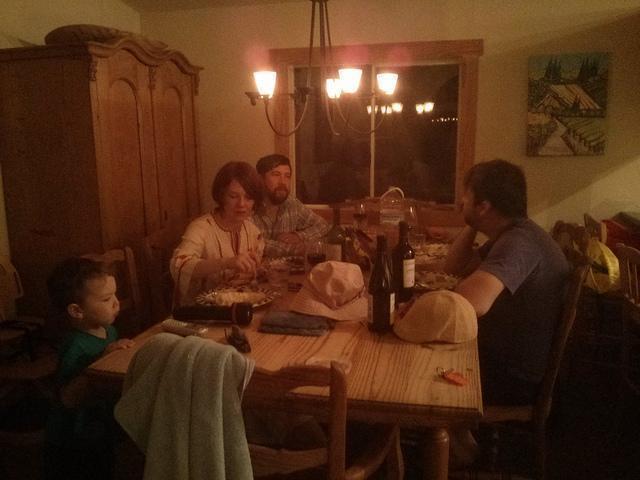Where are these people gathered?
Select the accurate answer and provide justification: `Answer: choice
Rationale: srationale.`
Options: Hospital, home, museum, restaurant. Answer: home.
Rationale: The people are in a dining room. it is too small to be part of a restaurant. 